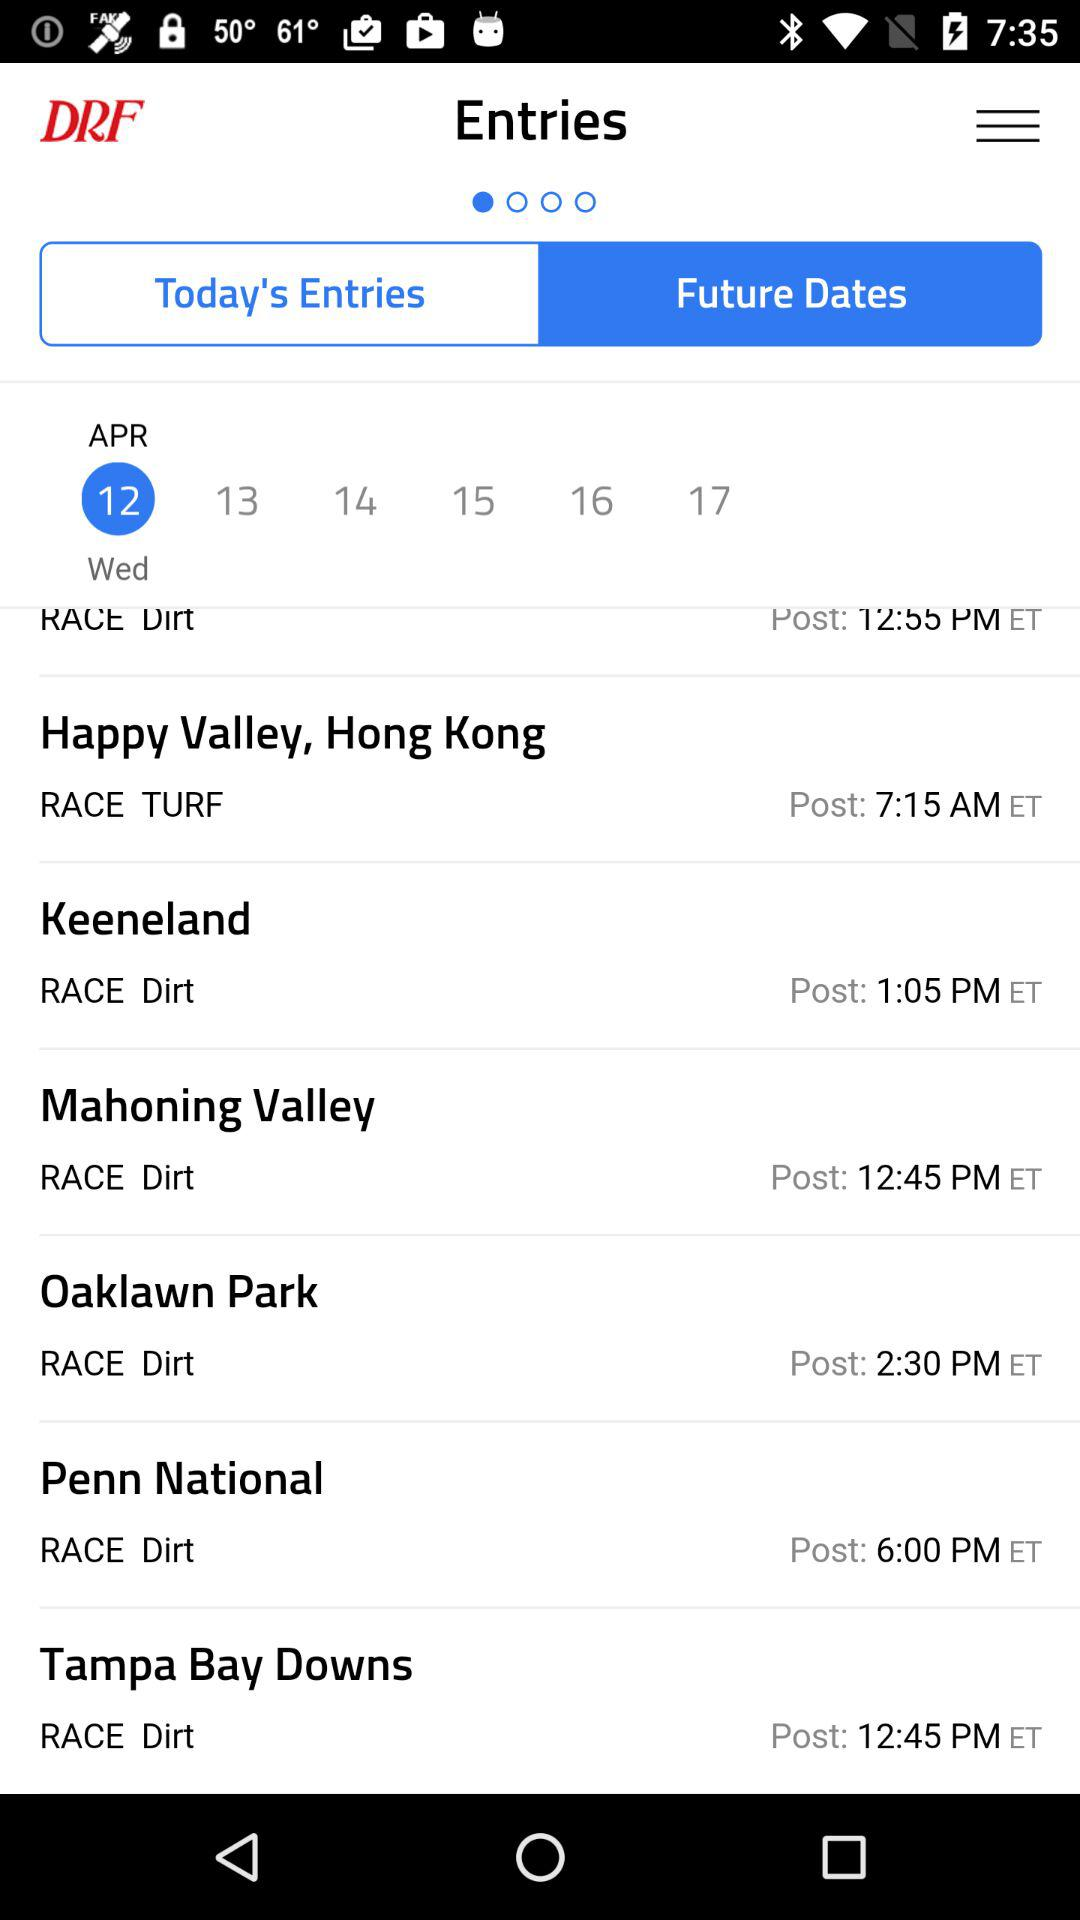What type of race is in Happy Valley, Hong Kong? The type of race is "TURF". 